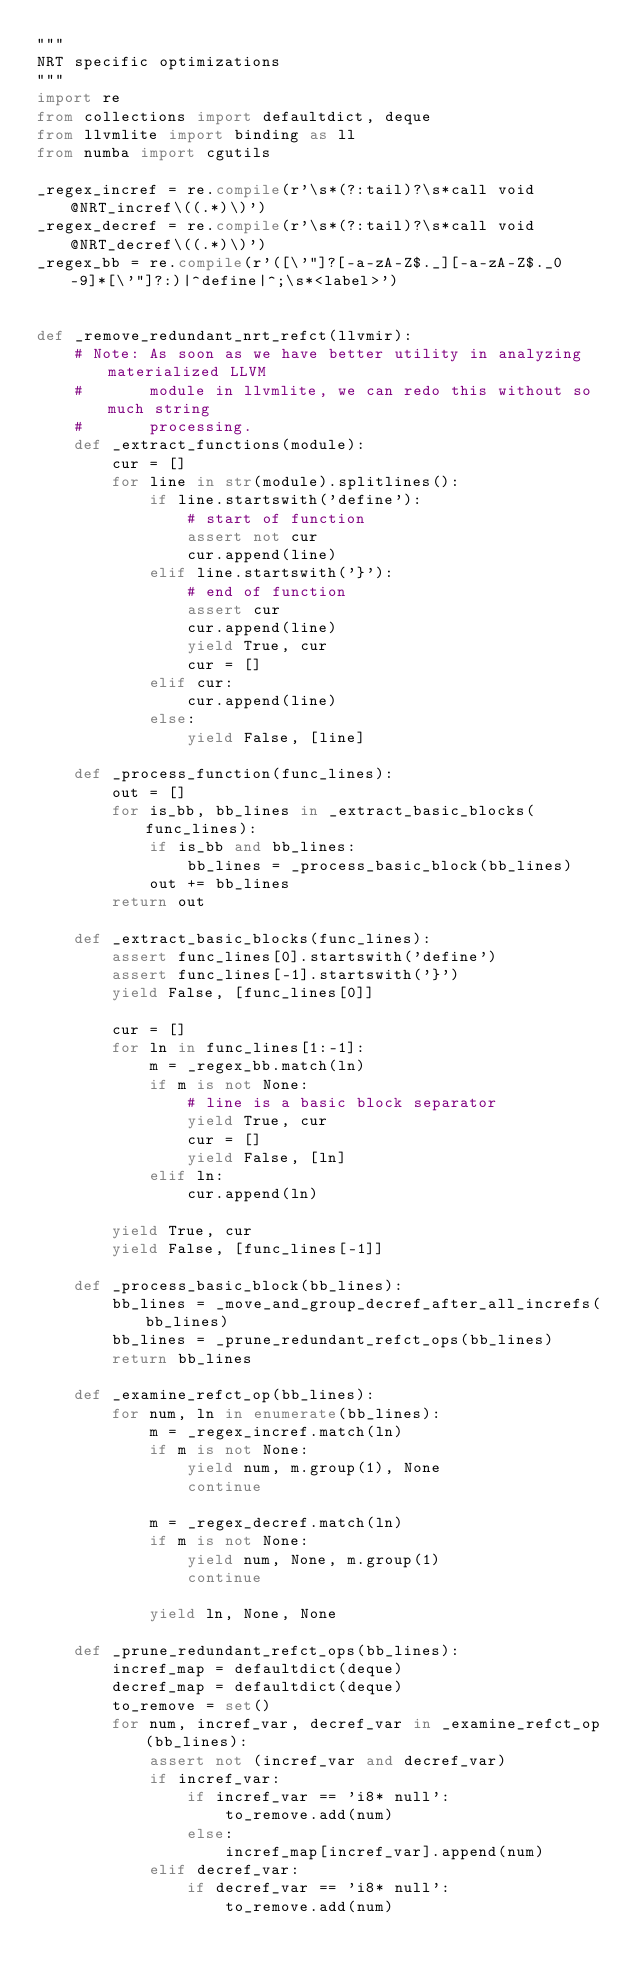<code> <loc_0><loc_0><loc_500><loc_500><_Python_>"""
NRT specific optimizations
"""
import re
from collections import defaultdict, deque
from llvmlite import binding as ll
from numba import cgutils

_regex_incref = re.compile(r'\s*(?:tail)?\s*call void @NRT_incref\((.*)\)')
_regex_decref = re.compile(r'\s*(?:tail)?\s*call void @NRT_decref\((.*)\)')
_regex_bb = re.compile(r'([\'"]?[-a-zA-Z$._][-a-zA-Z$._0-9]*[\'"]?:)|^define|^;\s*<label>')


def _remove_redundant_nrt_refct(llvmir):
    # Note: As soon as we have better utility in analyzing materialized LLVM
    #       module in llvmlite, we can redo this without so much string
    #       processing.
    def _extract_functions(module):
        cur = []
        for line in str(module).splitlines():
            if line.startswith('define'):
                # start of function
                assert not cur
                cur.append(line)
            elif line.startswith('}'):
                # end of function
                assert cur
                cur.append(line)
                yield True, cur
                cur = []
            elif cur:
                cur.append(line)
            else:
                yield False, [line]

    def _process_function(func_lines):
        out = []
        for is_bb, bb_lines in _extract_basic_blocks(func_lines):
            if is_bb and bb_lines:
                bb_lines = _process_basic_block(bb_lines)
            out += bb_lines
        return out

    def _extract_basic_blocks(func_lines):
        assert func_lines[0].startswith('define')
        assert func_lines[-1].startswith('}')
        yield False, [func_lines[0]]

        cur = []
        for ln in func_lines[1:-1]:
            m = _regex_bb.match(ln)
            if m is not None:
                # line is a basic block separator
                yield True, cur
                cur = []
                yield False, [ln]
            elif ln:
                cur.append(ln)

        yield True, cur
        yield False, [func_lines[-1]]

    def _process_basic_block(bb_lines):
        bb_lines = _move_and_group_decref_after_all_increfs(bb_lines)
        bb_lines = _prune_redundant_refct_ops(bb_lines)
        return bb_lines

    def _examine_refct_op(bb_lines):
        for num, ln in enumerate(bb_lines):
            m = _regex_incref.match(ln)
            if m is not None:
                yield num, m.group(1), None
                continue

            m = _regex_decref.match(ln)
            if m is not None:
                yield num, None, m.group(1)
                continue

            yield ln, None, None

    def _prune_redundant_refct_ops(bb_lines):
        incref_map = defaultdict(deque)
        decref_map = defaultdict(deque)
        to_remove = set()
        for num, incref_var, decref_var in _examine_refct_op(bb_lines):
            assert not (incref_var and decref_var)
            if incref_var:
                if incref_var == 'i8* null':
                    to_remove.add(num)
                else:
                    incref_map[incref_var].append(num)
            elif decref_var:
                if decref_var == 'i8* null':
                    to_remove.add(num)</code> 